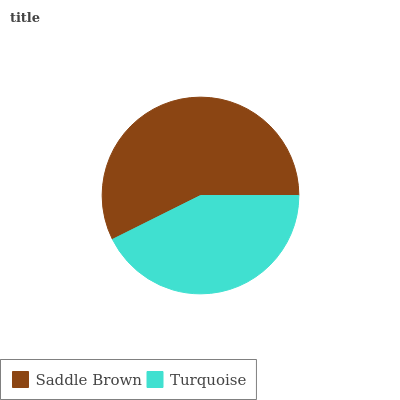Is Turquoise the minimum?
Answer yes or no. Yes. Is Saddle Brown the maximum?
Answer yes or no. Yes. Is Turquoise the maximum?
Answer yes or no. No. Is Saddle Brown greater than Turquoise?
Answer yes or no. Yes. Is Turquoise less than Saddle Brown?
Answer yes or no. Yes. Is Turquoise greater than Saddle Brown?
Answer yes or no. No. Is Saddle Brown less than Turquoise?
Answer yes or no. No. Is Saddle Brown the high median?
Answer yes or no. Yes. Is Turquoise the low median?
Answer yes or no. Yes. Is Turquoise the high median?
Answer yes or no. No. Is Saddle Brown the low median?
Answer yes or no. No. 